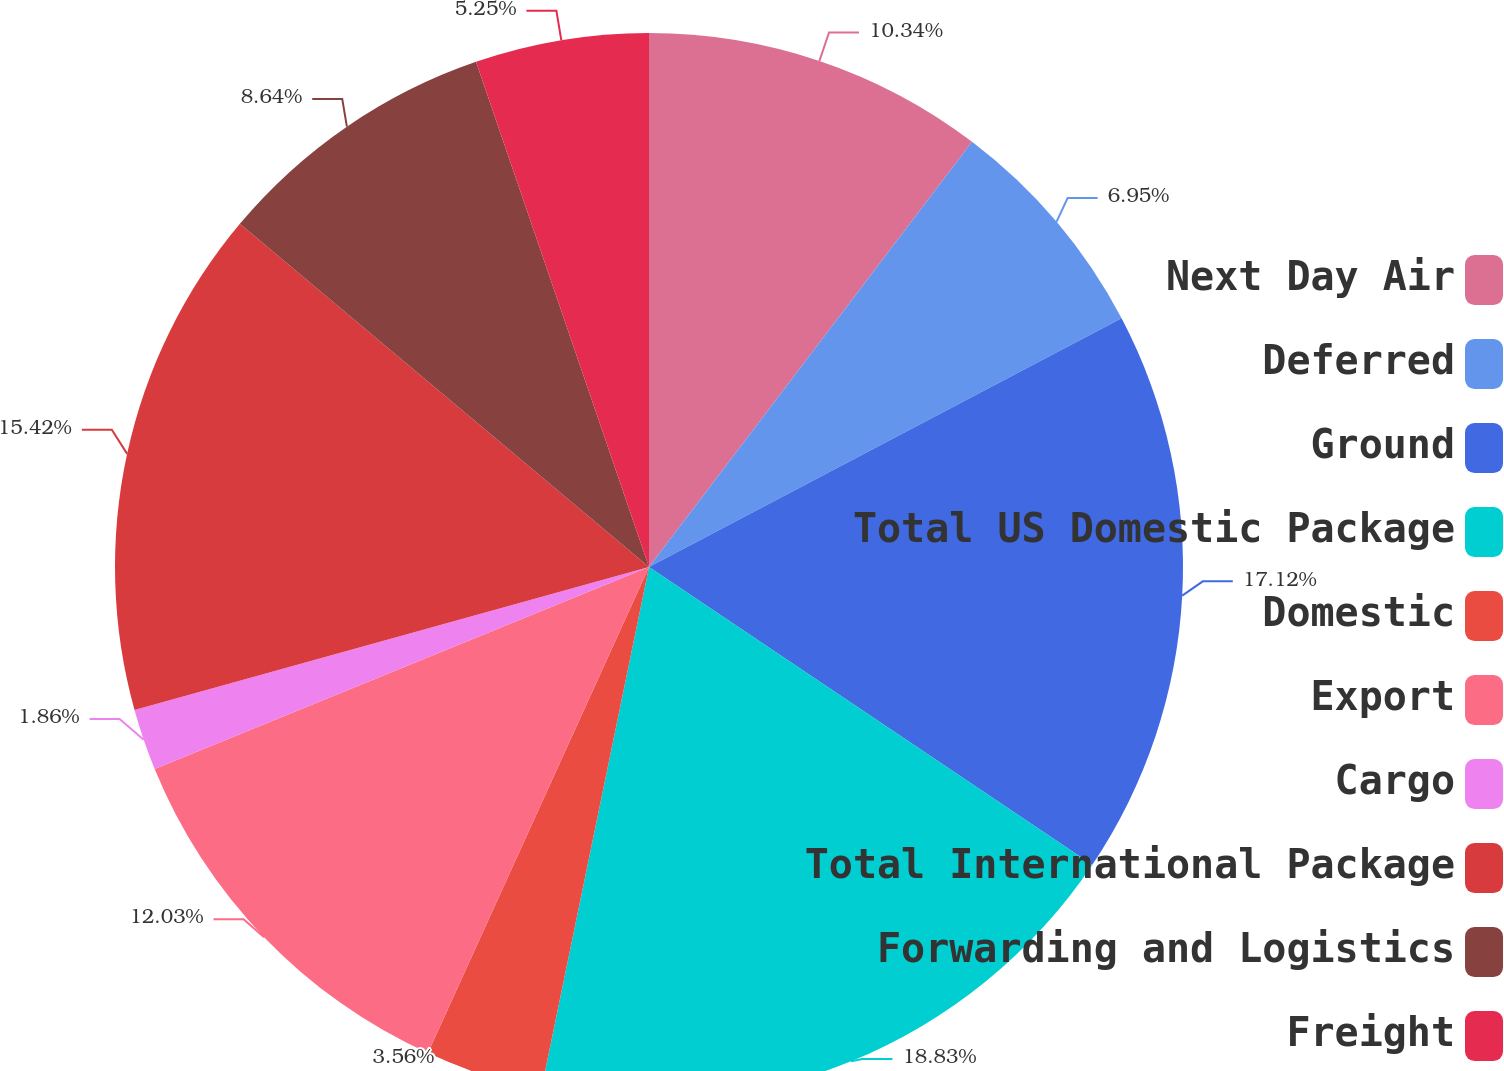<chart> <loc_0><loc_0><loc_500><loc_500><pie_chart><fcel>Next Day Air<fcel>Deferred<fcel>Ground<fcel>Total US Domestic Package<fcel>Domestic<fcel>Export<fcel>Cargo<fcel>Total International Package<fcel>Forwarding and Logistics<fcel>Freight<nl><fcel>10.34%<fcel>6.95%<fcel>17.12%<fcel>18.82%<fcel>3.56%<fcel>12.03%<fcel>1.86%<fcel>15.42%<fcel>8.64%<fcel>5.25%<nl></chart> 